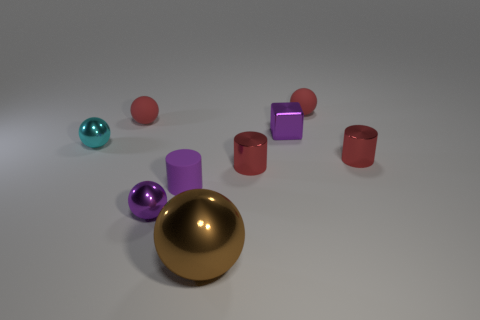There is a small matte thing that is on the right side of the large object; is its shape the same as the cyan shiny object?
Your response must be concise. Yes. Are there more tiny metal things behind the brown ball than small cylinders left of the purple metallic cube?
Give a very brief answer. Yes. How many big yellow things are the same material as the tiny purple sphere?
Your response must be concise. 0. Do the cyan sphere and the purple metallic cube have the same size?
Give a very brief answer. Yes. The large metal object is what color?
Offer a terse response. Brown. What number of things are either tiny red cylinders or small purple objects?
Ensure brevity in your answer.  5. Are there any large metal things that have the same shape as the small cyan thing?
Make the answer very short. Yes. Does the small shiny thing that is in front of the rubber cylinder have the same color as the cube?
Your answer should be very brief. Yes. What is the shape of the tiny purple thing right of the large brown metallic object in front of the shiny block?
Your answer should be compact. Cube. Is there a cyan object that has the same size as the purple cylinder?
Offer a very short reply. Yes. 